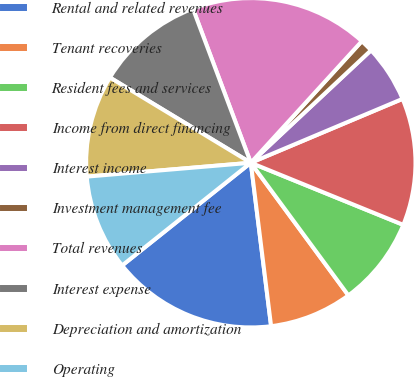Convert chart. <chart><loc_0><loc_0><loc_500><loc_500><pie_chart><fcel>Rental and related revenues<fcel>Tenant recoveries<fcel>Resident fees and services<fcel>Income from direct financing<fcel>Interest income<fcel>Investment management fee<fcel>Total revenues<fcel>Interest expense<fcel>Depreciation and amortization<fcel>Operating<nl><fcel>16.25%<fcel>8.13%<fcel>8.75%<fcel>12.5%<fcel>5.63%<fcel>1.25%<fcel>17.5%<fcel>10.62%<fcel>10.0%<fcel>9.38%<nl></chart> 